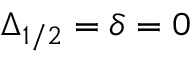Convert formula to latex. <formula><loc_0><loc_0><loc_500><loc_500>\Delta _ { 1 / 2 } = \delta = 0</formula> 